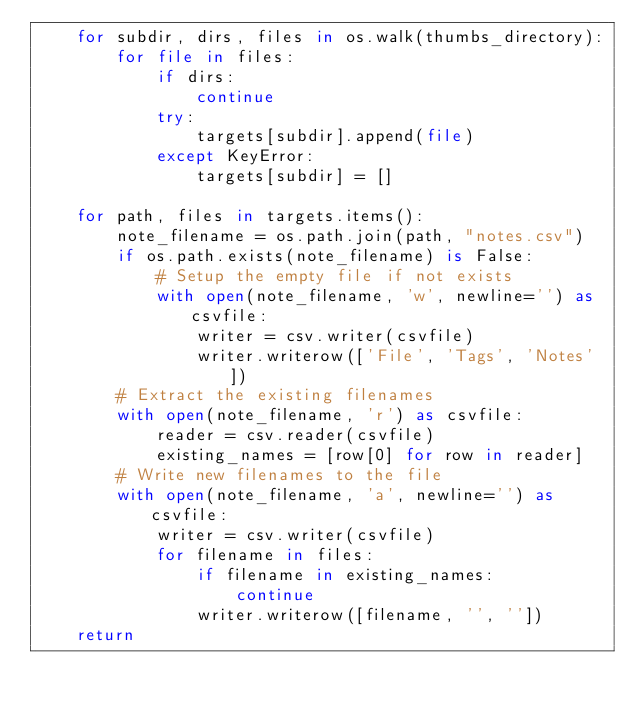Convert code to text. <code><loc_0><loc_0><loc_500><loc_500><_Python_>    for subdir, dirs, files in os.walk(thumbs_directory):
        for file in files:
            if dirs:
                continue
            try:
                targets[subdir].append(file)
            except KeyError:
                targets[subdir] = []

    for path, files in targets.items():
        note_filename = os.path.join(path, "notes.csv")
        if os.path.exists(note_filename) is False:
            # Setup the empty file if not exists
            with open(note_filename, 'w', newline='') as csvfile:
                writer = csv.writer(csvfile)
                writer.writerow(['File', 'Tags', 'Notes'])
        # Extract the existing filenames
        with open(note_filename, 'r') as csvfile:
            reader = csv.reader(csvfile)
            existing_names = [row[0] for row in reader]
        # Write new filenames to the file
        with open(note_filename, 'a', newline='') as csvfile:
            writer = csv.writer(csvfile)
            for filename in files:
                if filename in existing_names:
                    continue
                writer.writerow([filename, '', ''])
    return
</code> 